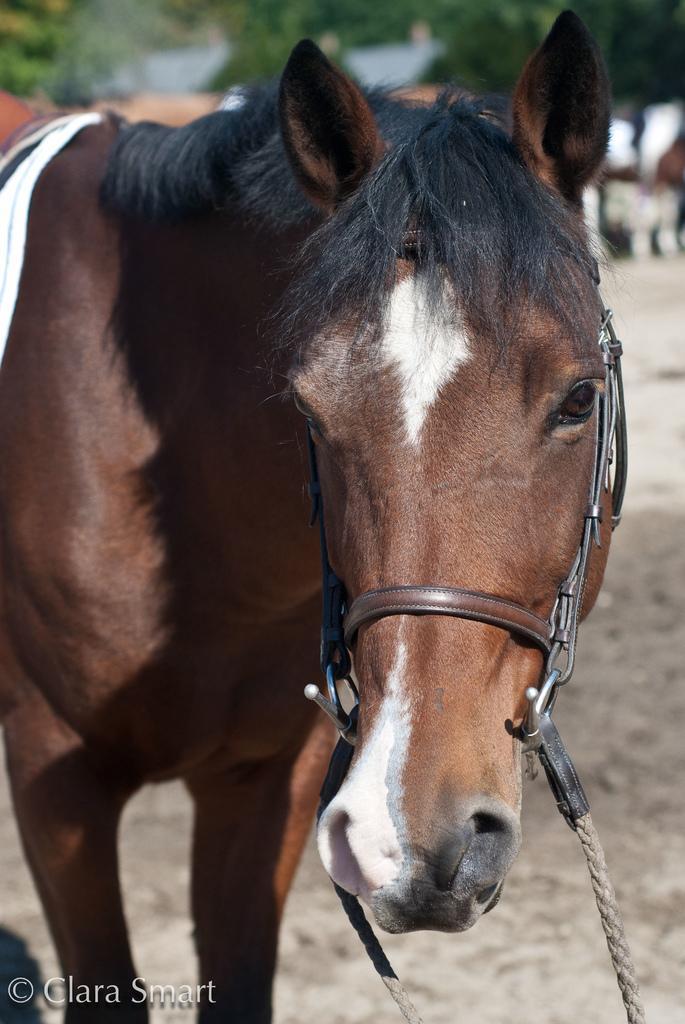Can you describe this image briefly? In the image i can see the animal and the background is blurry. 